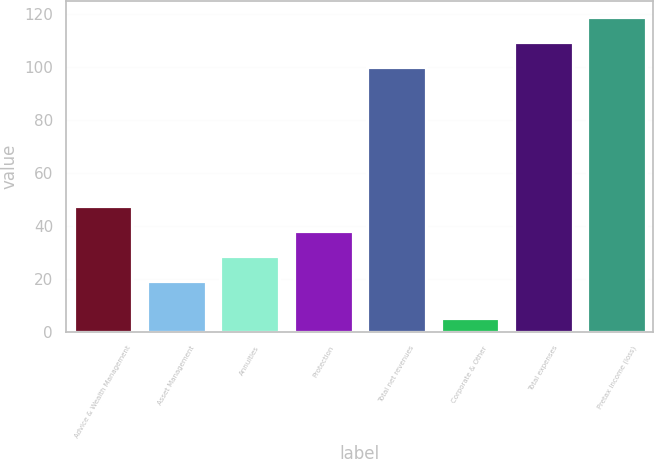Convert chart. <chart><loc_0><loc_0><loc_500><loc_500><bar_chart><fcel>Advice & Wealth Management<fcel>Asset Management<fcel>Annuities<fcel>Protection<fcel>Total net revenues<fcel>Corporate & Other<fcel>Total expenses<fcel>Pretax income (loss)<nl><fcel>47.5<fcel>19<fcel>28.5<fcel>38<fcel>100<fcel>5<fcel>109.5<fcel>119<nl></chart> 